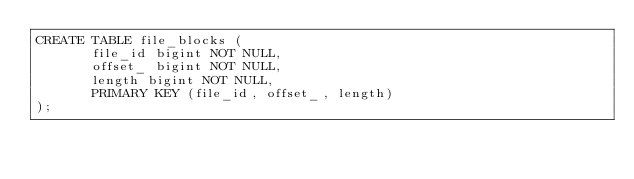Convert code to text. <code><loc_0><loc_0><loc_500><loc_500><_SQL_>CREATE TABLE file_blocks (
       file_id bigint NOT NULL,
       offset_ bigint NOT NULL,
       length bigint NOT NULL,
       PRIMARY KEY (file_id, offset_, length)
);
</code> 